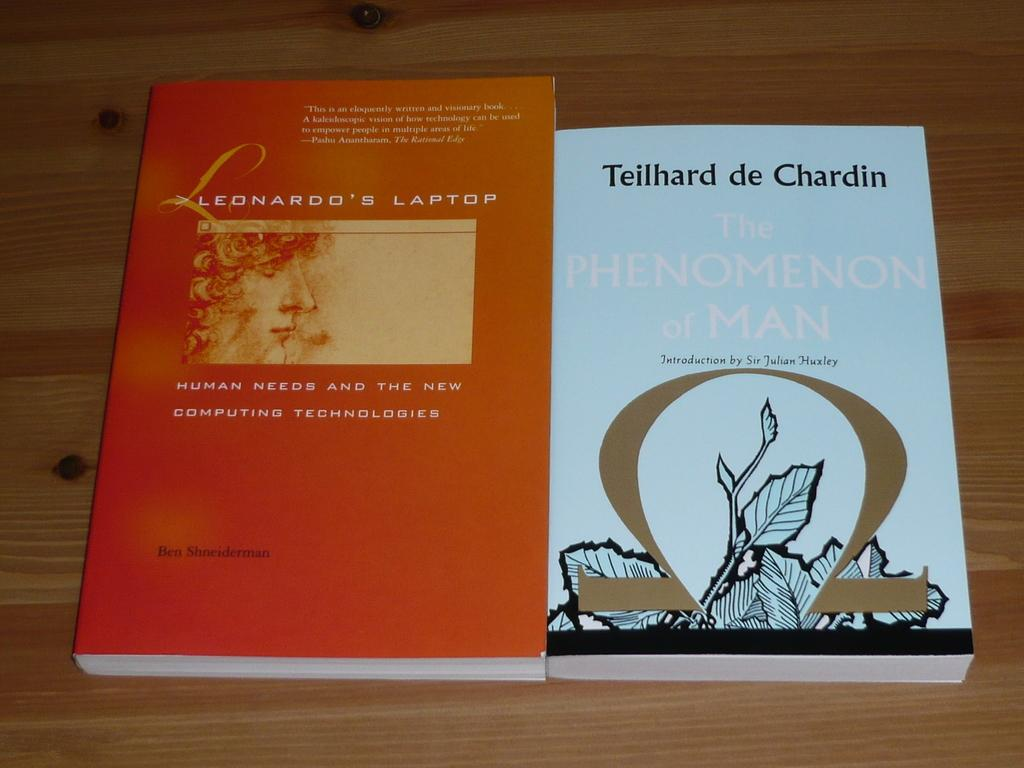<image>
Share a concise interpretation of the image provided. Two Novels Leonardo's Laptop and The Phenomenon of Man sits on a wooden table. 